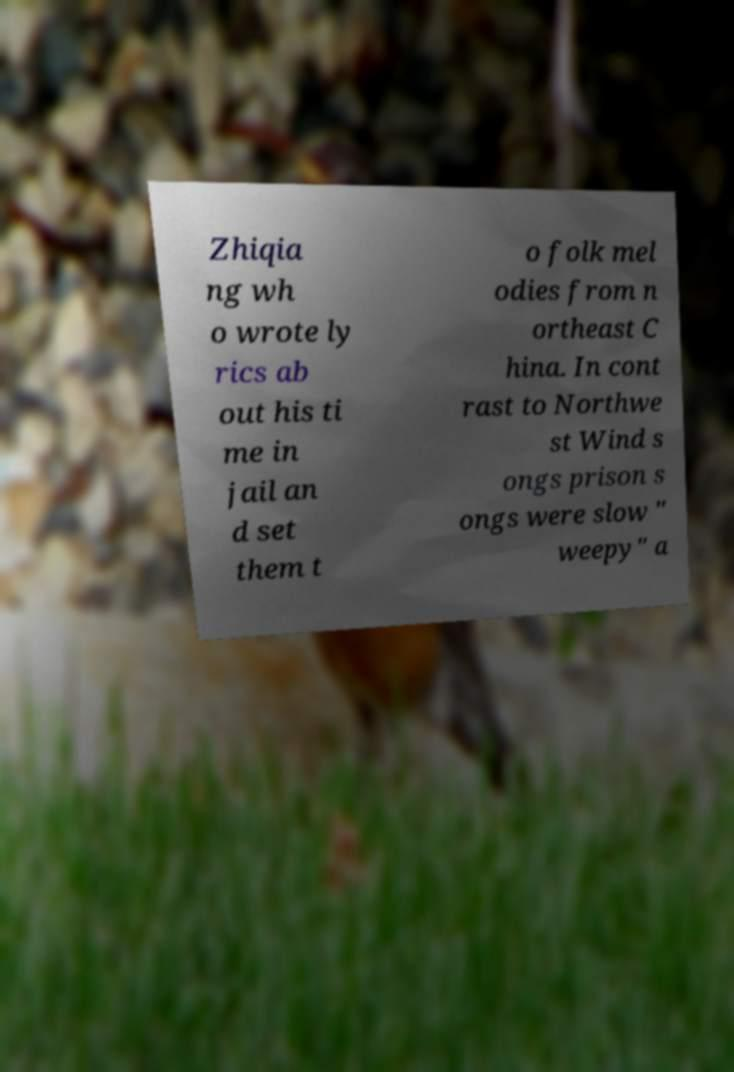Please read and relay the text visible in this image. What does it say? Zhiqia ng wh o wrote ly rics ab out his ti me in jail an d set them t o folk mel odies from n ortheast C hina. In cont rast to Northwe st Wind s ongs prison s ongs were slow " weepy" a 